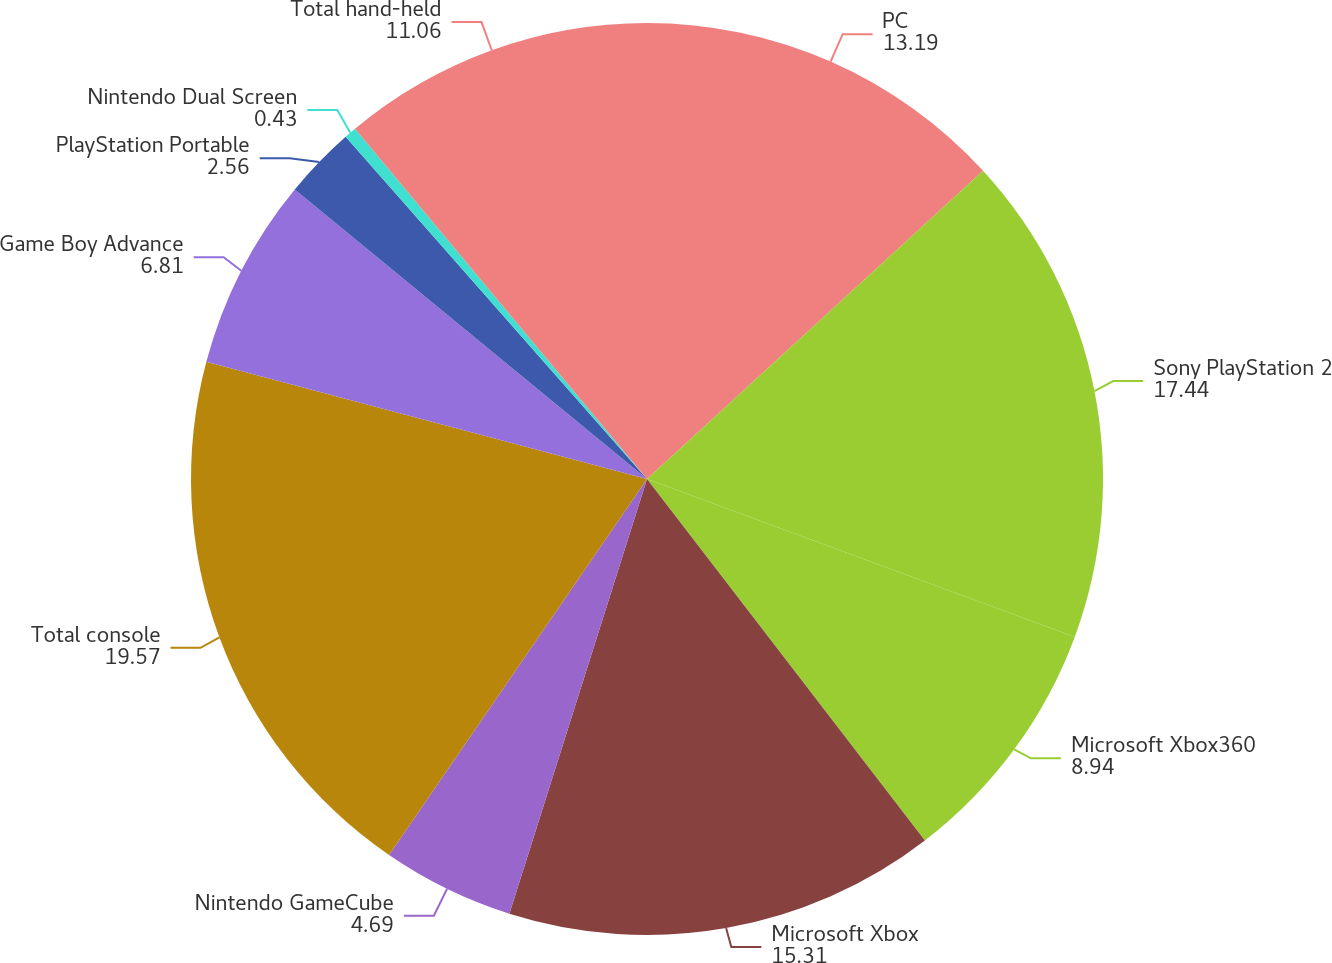Convert chart. <chart><loc_0><loc_0><loc_500><loc_500><pie_chart><fcel>PC<fcel>Sony PlayStation 2<fcel>Microsoft Xbox360<fcel>Microsoft Xbox<fcel>Nintendo GameCube<fcel>Total console<fcel>Game Boy Advance<fcel>PlayStation Portable<fcel>Nintendo Dual Screen<fcel>Total hand-held<nl><fcel>13.19%<fcel>17.44%<fcel>8.94%<fcel>15.31%<fcel>4.69%<fcel>19.57%<fcel>6.81%<fcel>2.56%<fcel>0.43%<fcel>11.06%<nl></chart> 